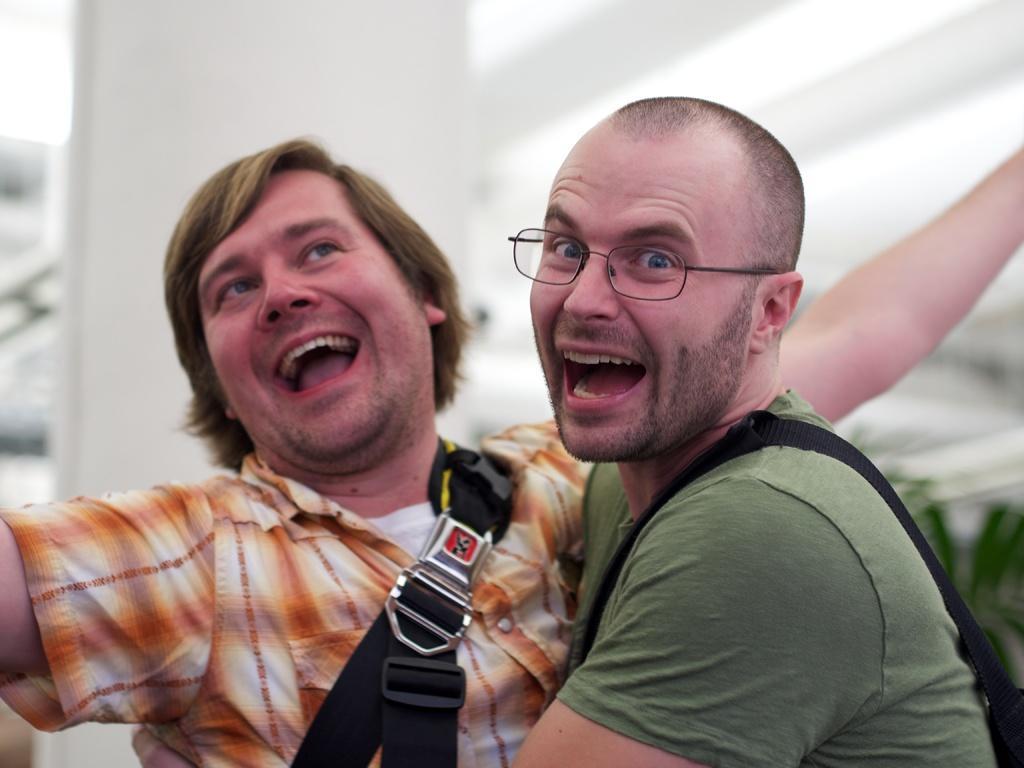Describe this image in one or two sentences. In the image in the center, we can see two persons are standing and they are smiling, which we can see on their faces. In the background there is a wall, pillar, roof and a few other objects. 